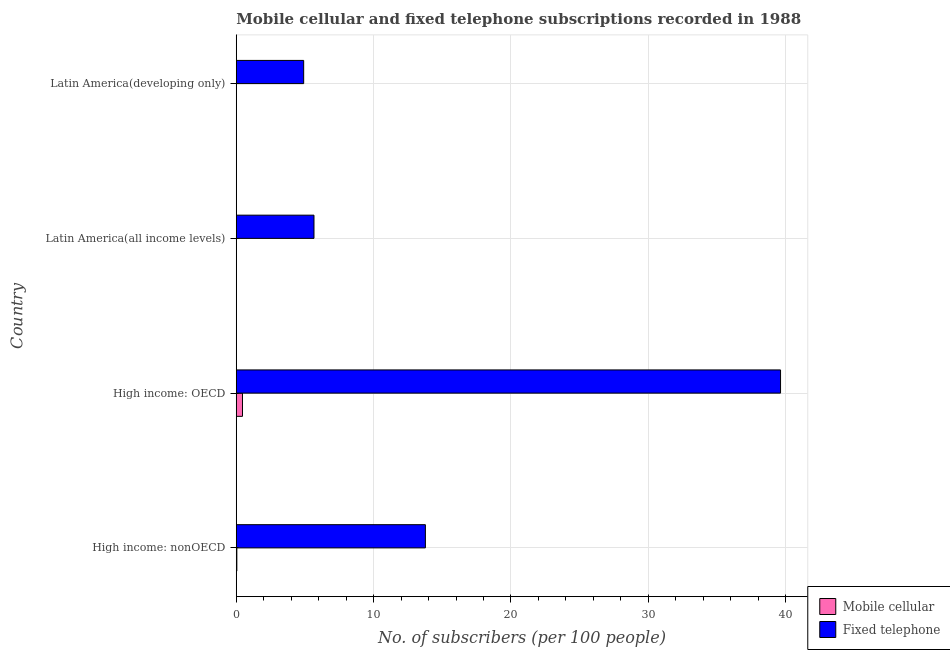Are the number of bars on each tick of the Y-axis equal?
Give a very brief answer. Yes. What is the label of the 4th group of bars from the top?
Offer a terse response. High income: nonOECD. What is the number of fixed telephone subscribers in High income: OECD?
Provide a succinct answer. 39.63. Across all countries, what is the maximum number of fixed telephone subscribers?
Provide a succinct answer. 39.63. Across all countries, what is the minimum number of fixed telephone subscribers?
Keep it short and to the point. 4.91. In which country was the number of mobile cellular subscribers maximum?
Give a very brief answer. High income: OECD. In which country was the number of mobile cellular subscribers minimum?
Offer a very short reply. Latin America(developing only). What is the total number of fixed telephone subscribers in the graph?
Give a very brief answer. 63.97. What is the difference between the number of mobile cellular subscribers in High income: nonOECD and that in Latin America(all income levels)?
Provide a succinct answer. 0.04. What is the difference between the number of mobile cellular subscribers in High income: nonOECD and the number of fixed telephone subscribers in Latin America(all income levels)?
Give a very brief answer. -5.62. What is the difference between the number of mobile cellular subscribers and number of fixed telephone subscribers in Latin America(all income levels)?
Your answer should be very brief. -5.66. In how many countries, is the number of fixed telephone subscribers greater than 38 ?
Offer a very short reply. 1. What is the ratio of the number of mobile cellular subscribers in High income: OECD to that in High income: nonOECD?
Your answer should be very brief. 10.59. Is the number of fixed telephone subscribers in High income: nonOECD less than that in Latin America(all income levels)?
Provide a short and direct response. No. Is the difference between the number of fixed telephone subscribers in High income: OECD and Latin America(developing only) greater than the difference between the number of mobile cellular subscribers in High income: OECD and Latin America(developing only)?
Your answer should be very brief. Yes. What is the difference between the highest and the second highest number of fixed telephone subscribers?
Your response must be concise. 25.86. What is the difference between the highest and the lowest number of fixed telephone subscribers?
Your answer should be compact. 34.72. In how many countries, is the number of fixed telephone subscribers greater than the average number of fixed telephone subscribers taken over all countries?
Your answer should be very brief. 1. What does the 2nd bar from the top in Latin America(all income levels) represents?
Make the answer very short. Mobile cellular. What does the 2nd bar from the bottom in High income: OECD represents?
Keep it short and to the point. Fixed telephone. Are all the bars in the graph horizontal?
Offer a very short reply. Yes. How many countries are there in the graph?
Provide a succinct answer. 4. Does the graph contain grids?
Provide a succinct answer. Yes. Where does the legend appear in the graph?
Provide a succinct answer. Bottom right. How many legend labels are there?
Keep it short and to the point. 2. What is the title of the graph?
Give a very brief answer. Mobile cellular and fixed telephone subscriptions recorded in 1988. What is the label or title of the X-axis?
Provide a short and direct response. No. of subscribers (per 100 people). What is the label or title of the Y-axis?
Provide a succinct answer. Country. What is the No. of subscribers (per 100 people) in Mobile cellular in High income: nonOECD?
Your answer should be very brief. 0.04. What is the No. of subscribers (per 100 people) of Fixed telephone in High income: nonOECD?
Your answer should be compact. 13.77. What is the No. of subscribers (per 100 people) in Mobile cellular in High income: OECD?
Offer a terse response. 0.45. What is the No. of subscribers (per 100 people) in Fixed telephone in High income: OECD?
Provide a short and direct response. 39.63. What is the No. of subscribers (per 100 people) in Mobile cellular in Latin America(all income levels)?
Provide a short and direct response. 0. What is the No. of subscribers (per 100 people) in Fixed telephone in Latin America(all income levels)?
Offer a very short reply. 5.66. What is the No. of subscribers (per 100 people) of Mobile cellular in Latin America(developing only)?
Provide a succinct answer. 0. What is the No. of subscribers (per 100 people) of Fixed telephone in Latin America(developing only)?
Provide a short and direct response. 4.91. Across all countries, what is the maximum No. of subscribers (per 100 people) of Mobile cellular?
Offer a terse response. 0.45. Across all countries, what is the maximum No. of subscribers (per 100 people) of Fixed telephone?
Provide a short and direct response. 39.63. Across all countries, what is the minimum No. of subscribers (per 100 people) of Mobile cellular?
Provide a succinct answer. 0. Across all countries, what is the minimum No. of subscribers (per 100 people) of Fixed telephone?
Your answer should be very brief. 4.91. What is the total No. of subscribers (per 100 people) of Mobile cellular in the graph?
Ensure brevity in your answer.  0.5. What is the total No. of subscribers (per 100 people) of Fixed telephone in the graph?
Give a very brief answer. 63.97. What is the difference between the No. of subscribers (per 100 people) in Mobile cellular in High income: nonOECD and that in High income: OECD?
Give a very brief answer. -0.41. What is the difference between the No. of subscribers (per 100 people) in Fixed telephone in High income: nonOECD and that in High income: OECD?
Provide a succinct answer. -25.86. What is the difference between the No. of subscribers (per 100 people) in Mobile cellular in High income: nonOECD and that in Latin America(all income levels)?
Your answer should be very brief. 0.04. What is the difference between the No. of subscribers (per 100 people) in Fixed telephone in High income: nonOECD and that in Latin America(all income levels)?
Keep it short and to the point. 8.11. What is the difference between the No. of subscribers (per 100 people) in Mobile cellular in High income: nonOECD and that in Latin America(developing only)?
Your answer should be very brief. 0.04. What is the difference between the No. of subscribers (per 100 people) in Fixed telephone in High income: nonOECD and that in Latin America(developing only)?
Your answer should be very brief. 8.86. What is the difference between the No. of subscribers (per 100 people) of Mobile cellular in High income: OECD and that in Latin America(all income levels)?
Offer a terse response. 0.45. What is the difference between the No. of subscribers (per 100 people) in Fixed telephone in High income: OECD and that in Latin America(all income levels)?
Your response must be concise. 33.97. What is the difference between the No. of subscribers (per 100 people) of Mobile cellular in High income: OECD and that in Latin America(developing only)?
Your answer should be compact. 0.45. What is the difference between the No. of subscribers (per 100 people) of Fixed telephone in High income: OECD and that in Latin America(developing only)?
Ensure brevity in your answer.  34.72. What is the difference between the No. of subscribers (per 100 people) in Mobile cellular in Latin America(all income levels) and that in Latin America(developing only)?
Ensure brevity in your answer.  0. What is the difference between the No. of subscribers (per 100 people) in Fixed telephone in Latin America(all income levels) and that in Latin America(developing only)?
Offer a very short reply. 0.75. What is the difference between the No. of subscribers (per 100 people) of Mobile cellular in High income: nonOECD and the No. of subscribers (per 100 people) of Fixed telephone in High income: OECD?
Offer a terse response. -39.58. What is the difference between the No. of subscribers (per 100 people) of Mobile cellular in High income: nonOECD and the No. of subscribers (per 100 people) of Fixed telephone in Latin America(all income levels)?
Provide a succinct answer. -5.62. What is the difference between the No. of subscribers (per 100 people) of Mobile cellular in High income: nonOECD and the No. of subscribers (per 100 people) of Fixed telephone in Latin America(developing only)?
Offer a very short reply. -4.87. What is the difference between the No. of subscribers (per 100 people) in Mobile cellular in High income: OECD and the No. of subscribers (per 100 people) in Fixed telephone in Latin America(all income levels)?
Ensure brevity in your answer.  -5.21. What is the difference between the No. of subscribers (per 100 people) of Mobile cellular in High income: OECD and the No. of subscribers (per 100 people) of Fixed telephone in Latin America(developing only)?
Your answer should be very brief. -4.45. What is the difference between the No. of subscribers (per 100 people) of Mobile cellular in Latin America(all income levels) and the No. of subscribers (per 100 people) of Fixed telephone in Latin America(developing only)?
Offer a very short reply. -4.91. What is the average No. of subscribers (per 100 people) of Fixed telephone per country?
Offer a terse response. 15.99. What is the difference between the No. of subscribers (per 100 people) in Mobile cellular and No. of subscribers (per 100 people) in Fixed telephone in High income: nonOECD?
Your response must be concise. -13.73. What is the difference between the No. of subscribers (per 100 people) in Mobile cellular and No. of subscribers (per 100 people) in Fixed telephone in High income: OECD?
Offer a very short reply. -39.17. What is the difference between the No. of subscribers (per 100 people) of Mobile cellular and No. of subscribers (per 100 people) of Fixed telephone in Latin America(all income levels)?
Keep it short and to the point. -5.66. What is the difference between the No. of subscribers (per 100 people) of Mobile cellular and No. of subscribers (per 100 people) of Fixed telephone in Latin America(developing only)?
Your answer should be compact. -4.91. What is the ratio of the No. of subscribers (per 100 people) in Mobile cellular in High income: nonOECD to that in High income: OECD?
Give a very brief answer. 0.09. What is the ratio of the No. of subscribers (per 100 people) in Fixed telephone in High income: nonOECD to that in High income: OECD?
Your answer should be very brief. 0.35. What is the ratio of the No. of subscribers (per 100 people) of Mobile cellular in High income: nonOECD to that in Latin America(all income levels)?
Offer a terse response. 15.03. What is the ratio of the No. of subscribers (per 100 people) of Fixed telephone in High income: nonOECD to that in Latin America(all income levels)?
Offer a very short reply. 2.43. What is the ratio of the No. of subscribers (per 100 people) of Mobile cellular in High income: nonOECD to that in Latin America(developing only)?
Your response must be concise. 99.72. What is the ratio of the No. of subscribers (per 100 people) of Fixed telephone in High income: nonOECD to that in Latin America(developing only)?
Provide a short and direct response. 2.81. What is the ratio of the No. of subscribers (per 100 people) in Mobile cellular in High income: OECD to that in Latin America(all income levels)?
Give a very brief answer. 159.1. What is the ratio of the No. of subscribers (per 100 people) of Fixed telephone in High income: OECD to that in Latin America(all income levels)?
Offer a very short reply. 7. What is the ratio of the No. of subscribers (per 100 people) in Mobile cellular in High income: OECD to that in Latin America(developing only)?
Your answer should be very brief. 1055.77. What is the ratio of the No. of subscribers (per 100 people) in Fixed telephone in High income: OECD to that in Latin America(developing only)?
Your answer should be compact. 8.07. What is the ratio of the No. of subscribers (per 100 people) of Mobile cellular in Latin America(all income levels) to that in Latin America(developing only)?
Your answer should be very brief. 6.64. What is the ratio of the No. of subscribers (per 100 people) in Fixed telephone in Latin America(all income levels) to that in Latin America(developing only)?
Offer a terse response. 1.15. What is the difference between the highest and the second highest No. of subscribers (per 100 people) in Mobile cellular?
Give a very brief answer. 0.41. What is the difference between the highest and the second highest No. of subscribers (per 100 people) of Fixed telephone?
Keep it short and to the point. 25.86. What is the difference between the highest and the lowest No. of subscribers (per 100 people) in Mobile cellular?
Your answer should be very brief. 0.45. What is the difference between the highest and the lowest No. of subscribers (per 100 people) of Fixed telephone?
Ensure brevity in your answer.  34.72. 